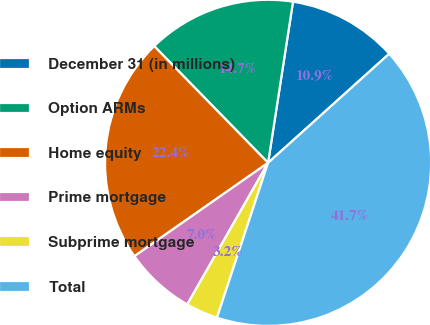<chart> <loc_0><loc_0><loc_500><loc_500><pie_chart><fcel>December 31 (in millions)<fcel>Option ARMs<fcel>Home equity<fcel>Prime mortgage<fcel>Subprime mortgage<fcel>Total<nl><fcel>10.89%<fcel>14.75%<fcel>22.4%<fcel>7.04%<fcel>3.18%<fcel>41.74%<nl></chart> 